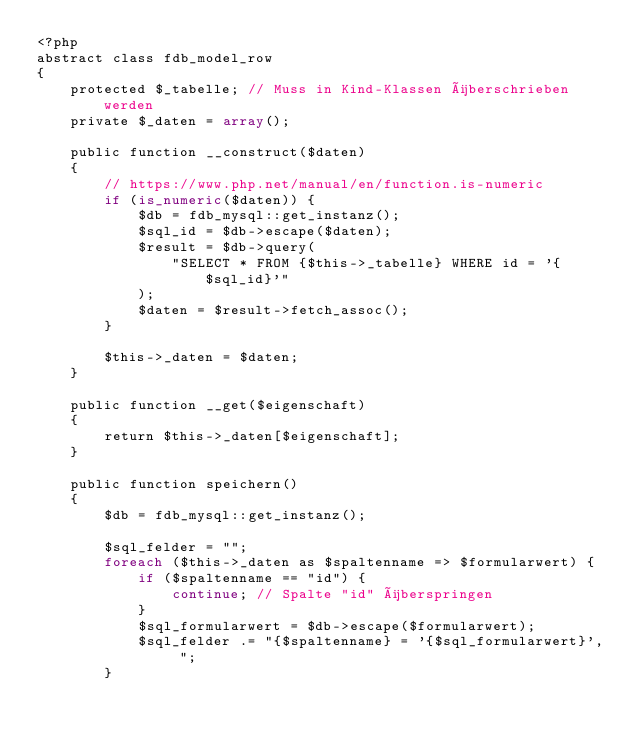Convert code to text. <code><loc_0><loc_0><loc_500><loc_500><_PHP_><?php
abstract class fdb_model_row
{
    protected $_tabelle; // Muss in Kind-Klassen überschrieben werden
    private $_daten = array();

    public function __construct($daten)
    {
        // https://www.php.net/manual/en/function.is-numeric
        if (is_numeric($daten)) {
            $db = fdb_mysql::get_instanz();
            $sql_id = $db->escape($daten);
            $result = $db->query(
                "SELECT * FROM {$this->_tabelle} WHERE id = '{$sql_id}'"
            );
            $daten = $result->fetch_assoc();
        }

        $this->_daten = $daten;
    }

    public function __get($eigenschaft)
    {
        return $this->_daten[$eigenschaft];
    }

    public function speichern()
    {
        $db = fdb_mysql::get_instanz();

        $sql_felder = "";
        foreach ($this->_daten as $spaltenname => $formularwert) {
            if ($spaltenname == "id") {
                continue; // Spalte "id" überspringen
            }
            $sql_formularwert = $db->escape($formularwert);
            $sql_felder .= "{$spaltenname} = '{$sql_formularwert}', ";
        }
</code> 